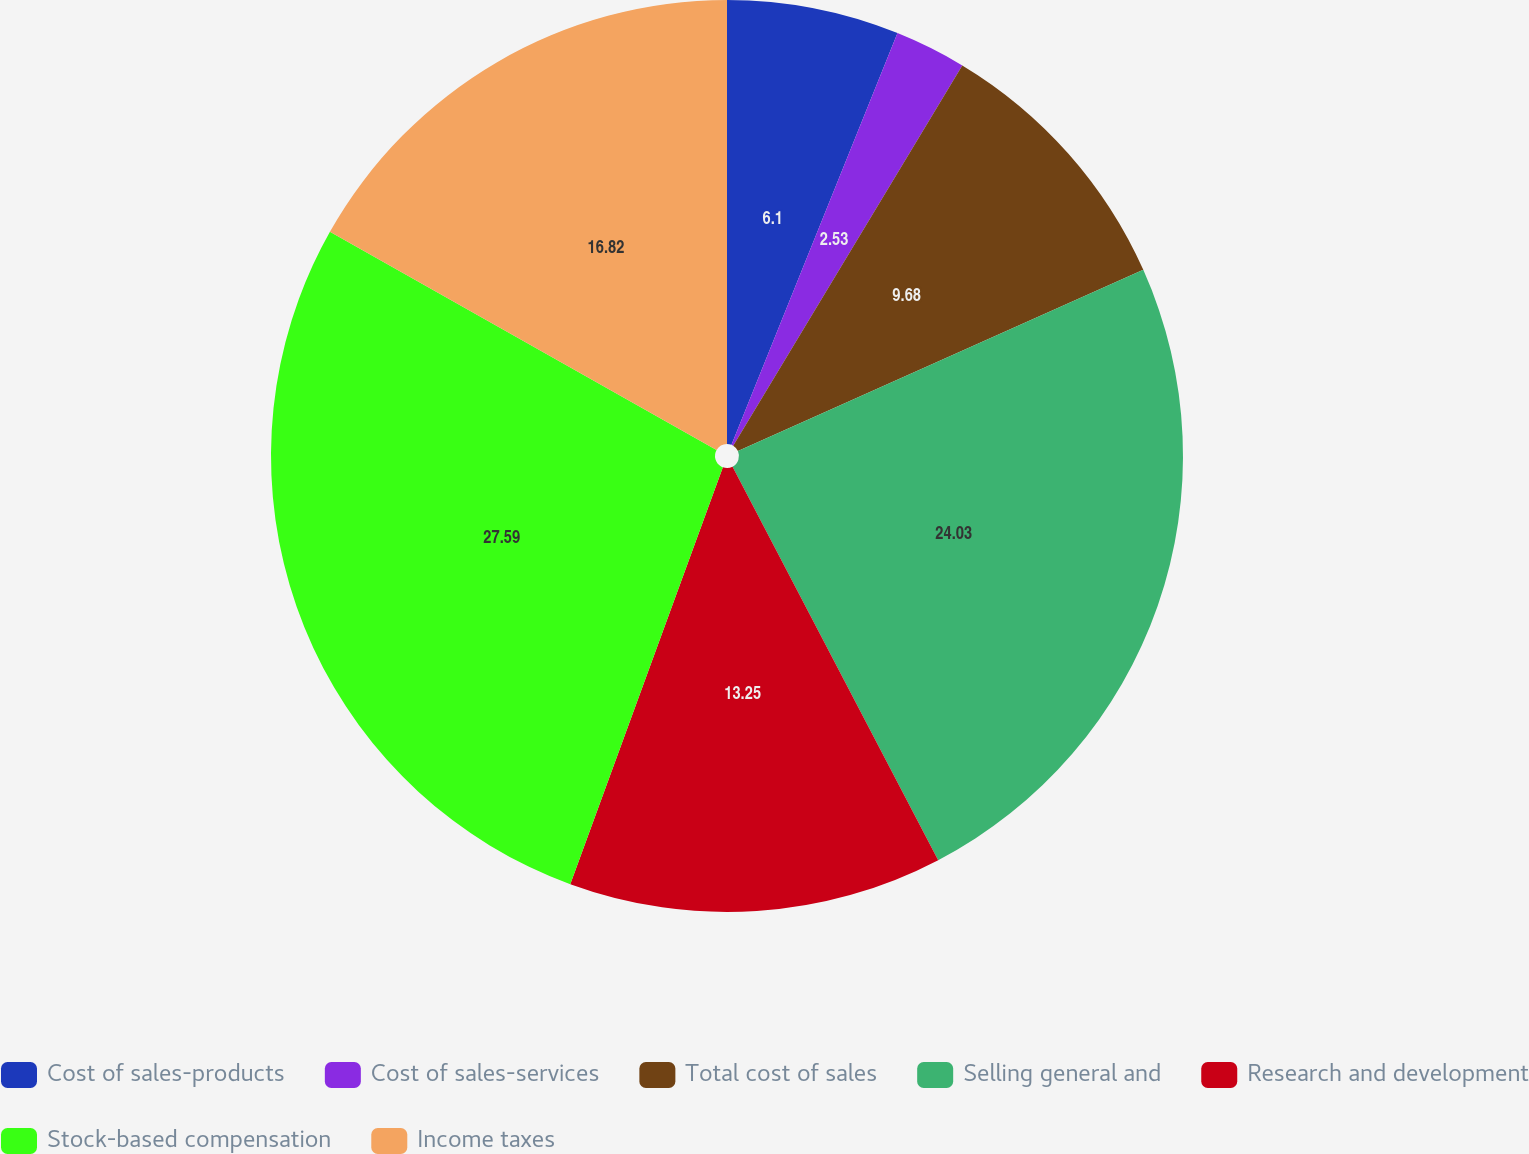<chart> <loc_0><loc_0><loc_500><loc_500><pie_chart><fcel>Cost of sales-products<fcel>Cost of sales-services<fcel>Total cost of sales<fcel>Selling general and<fcel>Research and development<fcel>Stock-based compensation<fcel>Income taxes<nl><fcel>6.1%<fcel>2.53%<fcel>9.68%<fcel>24.03%<fcel>13.25%<fcel>27.6%<fcel>16.82%<nl></chart> 